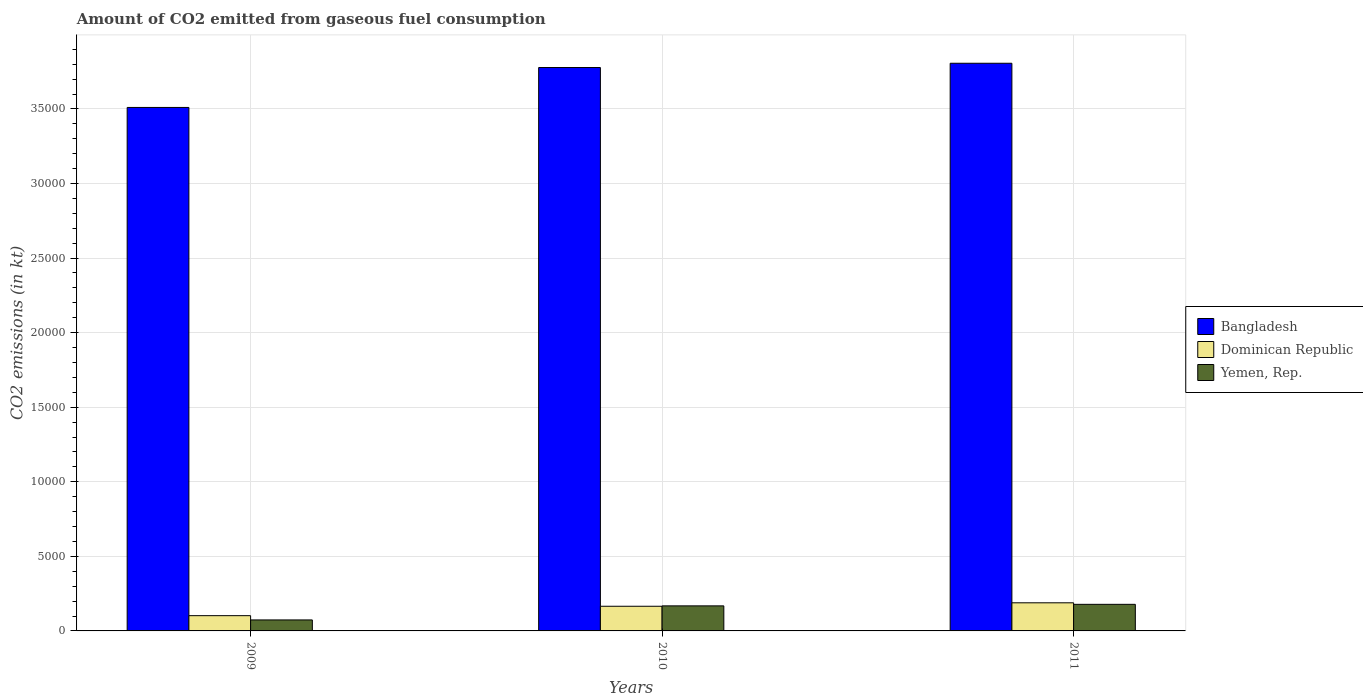How many bars are there on the 2nd tick from the left?
Provide a succinct answer. 3. How many bars are there on the 2nd tick from the right?
Your response must be concise. 3. What is the label of the 2nd group of bars from the left?
Offer a very short reply. 2010. What is the amount of CO2 emitted in Yemen, Rep. in 2010?
Provide a succinct answer. 1679.49. Across all years, what is the maximum amount of CO2 emitted in Dominican Republic?
Your answer should be compact. 1884.84. Across all years, what is the minimum amount of CO2 emitted in Yemen, Rep.?
Your answer should be very brief. 737.07. In which year was the amount of CO2 emitted in Dominican Republic minimum?
Offer a very short reply. 2009. What is the total amount of CO2 emitted in Bangladesh in the graph?
Ensure brevity in your answer.  1.11e+05. What is the difference between the amount of CO2 emitted in Dominican Republic in 2010 and that in 2011?
Your answer should be very brief. -231.02. What is the difference between the amount of CO2 emitted in Bangladesh in 2011 and the amount of CO2 emitted in Yemen, Rep. in 2010?
Ensure brevity in your answer.  3.64e+04. What is the average amount of CO2 emitted in Yemen, Rep. per year?
Make the answer very short. 1399.57. In the year 2011, what is the difference between the amount of CO2 emitted in Bangladesh and amount of CO2 emitted in Dominican Republic?
Give a very brief answer. 3.62e+04. In how many years, is the amount of CO2 emitted in Bangladesh greater than 21000 kt?
Your response must be concise. 3. What is the ratio of the amount of CO2 emitted in Yemen, Rep. in 2009 to that in 2010?
Offer a very short reply. 0.44. Is the amount of CO2 emitted in Dominican Republic in 2010 less than that in 2011?
Keep it short and to the point. Yes. What is the difference between the highest and the second highest amount of CO2 emitted in Yemen, Rep.?
Offer a very short reply. 102.68. What is the difference between the highest and the lowest amount of CO2 emitted in Bangladesh?
Your answer should be very brief. 2962.94. In how many years, is the amount of CO2 emitted in Yemen, Rep. greater than the average amount of CO2 emitted in Yemen, Rep. taken over all years?
Offer a terse response. 2. Is the sum of the amount of CO2 emitted in Bangladesh in 2010 and 2011 greater than the maximum amount of CO2 emitted in Dominican Republic across all years?
Offer a terse response. Yes. What does the 2nd bar from the left in 2010 represents?
Your answer should be compact. Dominican Republic. What does the 1st bar from the right in 2010 represents?
Give a very brief answer. Yemen, Rep. How many bars are there?
Make the answer very short. 9. How many years are there in the graph?
Provide a short and direct response. 3. What is the difference between two consecutive major ticks on the Y-axis?
Your response must be concise. 5000. Are the values on the major ticks of Y-axis written in scientific E-notation?
Your response must be concise. No. Does the graph contain any zero values?
Offer a terse response. No. Where does the legend appear in the graph?
Ensure brevity in your answer.  Center right. How many legend labels are there?
Give a very brief answer. 3. How are the legend labels stacked?
Keep it short and to the point. Vertical. What is the title of the graph?
Make the answer very short. Amount of CO2 emitted from gaseous fuel consumption. What is the label or title of the Y-axis?
Offer a very short reply. CO2 emissions (in kt). What is the CO2 emissions (in kt) of Bangladesh in 2009?
Ensure brevity in your answer.  3.51e+04. What is the CO2 emissions (in kt) of Dominican Republic in 2009?
Provide a short and direct response. 1023.09. What is the CO2 emissions (in kt) of Yemen, Rep. in 2009?
Provide a succinct answer. 737.07. What is the CO2 emissions (in kt) of Bangladesh in 2010?
Give a very brief answer. 3.78e+04. What is the CO2 emissions (in kt) of Dominican Republic in 2010?
Offer a very short reply. 1653.82. What is the CO2 emissions (in kt) in Yemen, Rep. in 2010?
Offer a terse response. 1679.49. What is the CO2 emissions (in kt) in Bangladesh in 2011?
Make the answer very short. 3.81e+04. What is the CO2 emissions (in kt) in Dominican Republic in 2011?
Your answer should be very brief. 1884.84. What is the CO2 emissions (in kt) of Yemen, Rep. in 2011?
Make the answer very short. 1782.16. Across all years, what is the maximum CO2 emissions (in kt) in Bangladesh?
Give a very brief answer. 3.81e+04. Across all years, what is the maximum CO2 emissions (in kt) in Dominican Republic?
Keep it short and to the point. 1884.84. Across all years, what is the maximum CO2 emissions (in kt) in Yemen, Rep.?
Provide a succinct answer. 1782.16. Across all years, what is the minimum CO2 emissions (in kt) of Bangladesh?
Keep it short and to the point. 3.51e+04. Across all years, what is the minimum CO2 emissions (in kt) in Dominican Republic?
Make the answer very short. 1023.09. Across all years, what is the minimum CO2 emissions (in kt) in Yemen, Rep.?
Provide a succinct answer. 737.07. What is the total CO2 emissions (in kt) in Bangladesh in the graph?
Your response must be concise. 1.11e+05. What is the total CO2 emissions (in kt) of Dominican Republic in the graph?
Ensure brevity in your answer.  4561.75. What is the total CO2 emissions (in kt) in Yemen, Rep. in the graph?
Make the answer very short. 4198.72. What is the difference between the CO2 emissions (in kt) of Bangladesh in 2009 and that in 2010?
Keep it short and to the point. -2676.91. What is the difference between the CO2 emissions (in kt) of Dominican Republic in 2009 and that in 2010?
Your answer should be very brief. -630.72. What is the difference between the CO2 emissions (in kt) of Yemen, Rep. in 2009 and that in 2010?
Ensure brevity in your answer.  -942.42. What is the difference between the CO2 emissions (in kt) in Bangladesh in 2009 and that in 2011?
Make the answer very short. -2962.94. What is the difference between the CO2 emissions (in kt) in Dominican Republic in 2009 and that in 2011?
Provide a succinct answer. -861.75. What is the difference between the CO2 emissions (in kt) in Yemen, Rep. in 2009 and that in 2011?
Your response must be concise. -1045.1. What is the difference between the CO2 emissions (in kt) in Bangladesh in 2010 and that in 2011?
Your answer should be compact. -286.03. What is the difference between the CO2 emissions (in kt) in Dominican Republic in 2010 and that in 2011?
Offer a terse response. -231.02. What is the difference between the CO2 emissions (in kt) of Yemen, Rep. in 2010 and that in 2011?
Offer a very short reply. -102.68. What is the difference between the CO2 emissions (in kt) of Bangladesh in 2009 and the CO2 emissions (in kt) of Dominican Republic in 2010?
Your answer should be very brief. 3.34e+04. What is the difference between the CO2 emissions (in kt) in Bangladesh in 2009 and the CO2 emissions (in kt) in Yemen, Rep. in 2010?
Give a very brief answer. 3.34e+04. What is the difference between the CO2 emissions (in kt) of Dominican Republic in 2009 and the CO2 emissions (in kt) of Yemen, Rep. in 2010?
Offer a very short reply. -656.39. What is the difference between the CO2 emissions (in kt) of Bangladesh in 2009 and the CO2 emissions (in kt) of Dominican Republic in 2011?
Ensure brevity in your answer.  3.32e+04. What is the difference between the CO2 emissions (in kt) of Bangladesh in 2009 and the CO2 emissions (in kt) of Yemen, Rep. in 2011?
Your response must be concise. 3.33e+04. What is the difference between the CO2 emissions (in kt) in Dominican Republic in 2009 and the CO2 emissions (in kt) in Yemen, Rep. in 2011?
Provide a short and direct response. -759.07. What is the difference between the CO2 emissions (in kt) in Bangladesh in 2010 and the CO2 emissions (in kt) in Dominican Republic in 2011?
Your answer should be very brief. 3.59e+04. What is the difference between the CO2 emissions (in kt) of Bangladesh in 2010 and the CO2 emissions (in kt) of Yemen, Rep. in 2011?
Your response must be concise. 3.60e+04. What is the difference between the CO2 emissions (in kt) in Dominican Republic in 2010 and the CO2 emissions (in kt) in Yemen, Rep. in 2011?
Your response must be concise. -128.34. What is the average CO2 emissions (in kt) in Bangladesh per year?
Your answer should be compact. 3.70e+04. What is the average CO2 emissions (in kt) in Dominican Republic per year?
Give a very brief answer. 1520.58. What is the average CO2 emissions (in kt) in Yemen, Rep. per year?
Offer a terse response. 1399.57. In the year 2009, what is the difference between the CO2 emissions (in kt) in Bangladesh and CO2 emissions (in kt) in Dominican Republic?
Your answer should be compact. 3.41e+04. In the year 2009, what is the difference between the CO2 emissions (in kt) in Bangladesh and CO2 emissions (in kt) in Yemen, Rep.?
Provide a short and direct response. 3.44e+04. In the year 2009, what is the difference between the CO2 emissions (in kt) in Dominican Republic and CO2 emissions (in kt) in Yemen, Rep.?
Offer a very short reply. 286.03. In the year 2010, what is the difference between the CO2 emissions (in kt) of Bangladesh and CO2 emissions (in kt) of Dominican Republic?
Your answer should be very brief. 3.61e+04. In the year 2010, what is the difference between the CO2 emissions (in kt) of Bangladesh and CO2 emissions (in kt) of Yemen, Rep.?
Provide a succinct answer. 3.61e+04. In the year 2010, what is the difference between the CO2 emissions (in kt) of Dominican Republic and CO2 emissions (in kt) of Yemen, Rep.?
Give a very brief answer. -25.67. In the year 2011, what is the difference between the CO2 emissions (in kt) of Bangladesh and CO2 emissions (in kt) of Dominican Republic?
Offer a terse response. 3.62e+04. In the year 2011, what is the difference between the CO2 emissions (in kt) in Bangladesh and CO2 emissions (in kt) in Yemen, Rep.?
Give a very brief answer. 3.63e+04. In the year 2011, what is the difference between the CO2 emissions (in kt) in Dominican Republic and CO2 emissions (in kt) in Yemen, Rep.?
Provide a short and direct response. 102.68. What is the ratio of the CO2 emissions (in kt) in Bangladesh in 2009 to that in 2010?
Your answer should be compact. 0.93. What is the ratio of the CO2 emissions (in kt) of Dominican Republic in 2009 to that in 2010?
Ensure brevity in your answer.  0.62. What is the ratio of the CO2 emissions (in kt) in Yemen, Rep. in 2009 to that in 2010?
Your answer should be very brief. 0.44. What is the ratio of the CO2 emissions (in kt) of Bangladesh in 2009 to that in 2011?
Your response must be concise. 0.92. What is the ratio of the CO2 emissions (in kt) of Dominican Republic in 2009 to that in 2011?
Give a very brief answer. 0.54. What is the ratio of the CO2 emissions (in kt) of Yemen, Rep. in 2009 to that in 2011?
Give a very brief answer. 0.41. What is the ratio of the CO2 emissions (in kt) of Bangladesh in 2010 to that in 2011?
Offer a very short reply. 0.99. What is the ratio of the CO2 emissions (in kt) in Dominican Republic in 2010 to that in 2011?
Make the answer very short. 0.88. What is the ratio of the CO2 emissions (in kt) in Yemen, Rep. in 2010 to that in 2011?
Ensure brevity in your answer.  0.94. What is the difference between the highest and the second highest CO2 emissions (in kt) in Bangladesh?
Your response must be concise. 286.03. What is the difference between the highest and the second highest CO2 emissions (in kt) of Dominican Republic?
Your answer should be compact. 231.02. What is the difference between the highest and the second highest CO2 emissions (in kt) in Yemen, Rep.?
Your answer should be compact. 102.68. What is the difference between the highest and the lowest CO2 emissions (in kt) of Bangladesh?
Provide a short and direct response. 2962.94. What is the difference between the highest and the lowest CO2 emissions (in kt) of Dominican Republic?
Give a very brief answer. 861.75. What is the difference between the highest and the lowest CO2 emissions (in kt) in Yemen, Rep.?
Offer a terse response. 1045.1. 